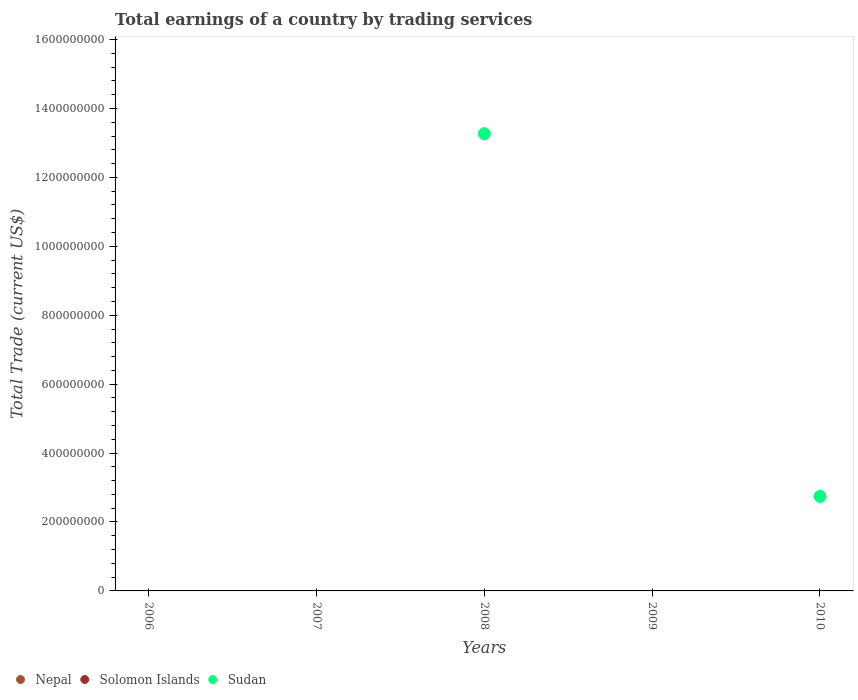Is the number of dotlines equal to the number of legend labels?
Your answer should be compact. No. Across all years, what is the maximum total earnings in Sudan?
Keep it short and to the point. 1.33e+09. In which year was the total earnings in Sudan maximum?
Your answer should be very brief. 2008. What is the total total earnings in Nepal in the graph?
Your response must be concise. 0. What is the difference between the total earnings in Sudan in 2008 and the total earnings in Nepal in 2009?
Ensure brevity in your answer.  1.33e+09. What is the average total earnings in Nepal per year?
Your response must be concise. 0. In how many years, is the total earnings in Solomon Islands greater than 720000000 US$?
Ensure brevity in your answer.  0. What is the difference between the highest and the lowest total earnings in Sudan?
Make the answer very short. 1.33e+09. Is it the case that in every year, the sum of the total earnings in Sudan and total earnings in Solomon Islands  is greater than the total earnings in Nepal?
Offer a terse response. No. Does the total earnings in Solomon Islands monotonically increase over the years?
Make the answer very short. No. Is the total earnings in Sudan strictly less than the total earnings in Solomon Islands over the years?
Your answer should be very brief. No. What is the difference between two consecutive major ticks on the Y-axis?
Your answer should be very brief. 2.00e+08. Are the values on the major ticks of Y-axis written in scientific E-notation?
Provide a succinct answer. No. Does the graph contain grids?
Give a very brief answer. No. Where does the legend appear in the graph?
Ensure brevity in your answer.  Bottom left. How many legend labels are there?
Ensure brevity in your answer.  3. What is the title of the graph?
Keep it short and to the point. Total earnings of a country by trading services. Does "Slovenia" appear as one of the legend labels in the graph?
Provide a short and direct response. No. What is the label or title of the Y-axis?
Your answer should be very brief. Total Trade (current US$). What is the Total Trade (current US$) in Nepal in 2006?
Your answer should be compact. 0. What is the Total Trade (current US$) in Solomon Islands in 2006?
Your answer should be very brief. 0. What is the Total Trade (current US$) in Sudan in 2006?
Ensure brevity in your answer.  0. What is the Total Trade (current US$) in Nepal in 2007?
Offer a very short reply. 0. What is the Total Trade (current US$) in Sudan in 2007?
Give a very brief answer. 0. What is the Total Trade (current US$) in Sudan in 2008?
Offer a very short reply. 1.33e+09. What is the Total Trade (current US$) in Nepal in 2009?
Ensure brevity in your answer.  0. What is the Total Trade (current US$) in Nepal in 2010?
Offer a terse response. 0. What is the Total Trade (current US$) of Solomon Islands in 2010?
Offer a very short reply. 0. What is the Total Trade (current US$) in Sudan in 2010?
Give a very brief answer. 2.74e+08. Across all years, what is the maximum Total Trade (current US$) of Sudan?
Your answer should be compact. 1.33e+09. Across all years, what is the minimum Total Trade (current US$) in Sudan?
Your answer should be very brief. 0. What is the total Total Trade (current US$) of Nepal in the graph?
Your response must be concise. 0. What is the total Total Trade (current US$) of Solomon Islands in the graph?
Give a very brief answer. 0. What is the total Total Trade (current US$) of Sudan in the graph?
Give a very brief answer. 1.60e+09. What is the difference between the Total Trade (current US$) in Sudan in 2008 and that in 2010?
Offer a very short reply. 1.05e+09. What is the average Total Trade (current US$) of Sudan per year?
Your answer should be very brief. 3.20e+08. What is the ratio of the Total Trade (current US$) of Sudan in 2008 to that in 2010?
Your response must be concise. 4.83. What is the difference between the highest and the lowest Total Trade (current US$) in Sudan?
Provide a succinct answer. 1.33e+09. 